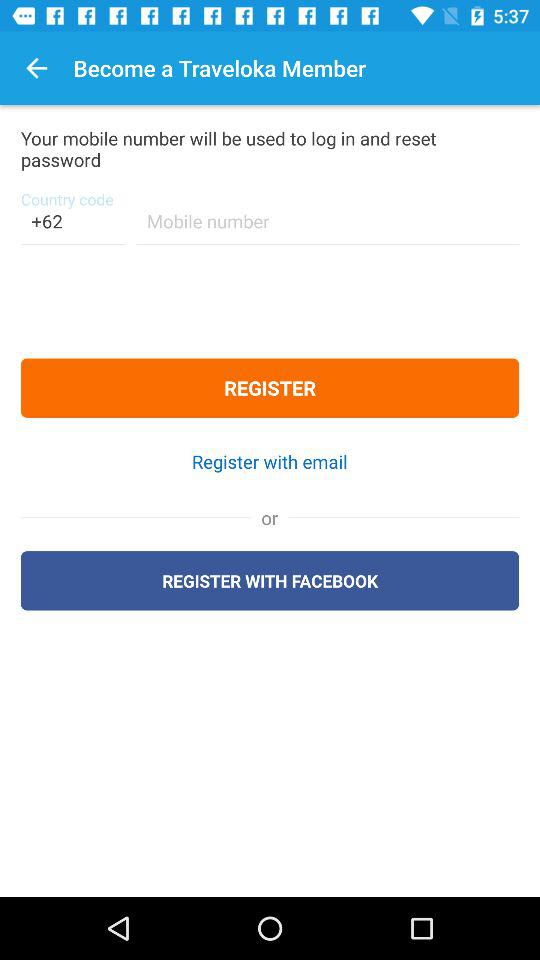What is the country code given? The given country code is +62. 